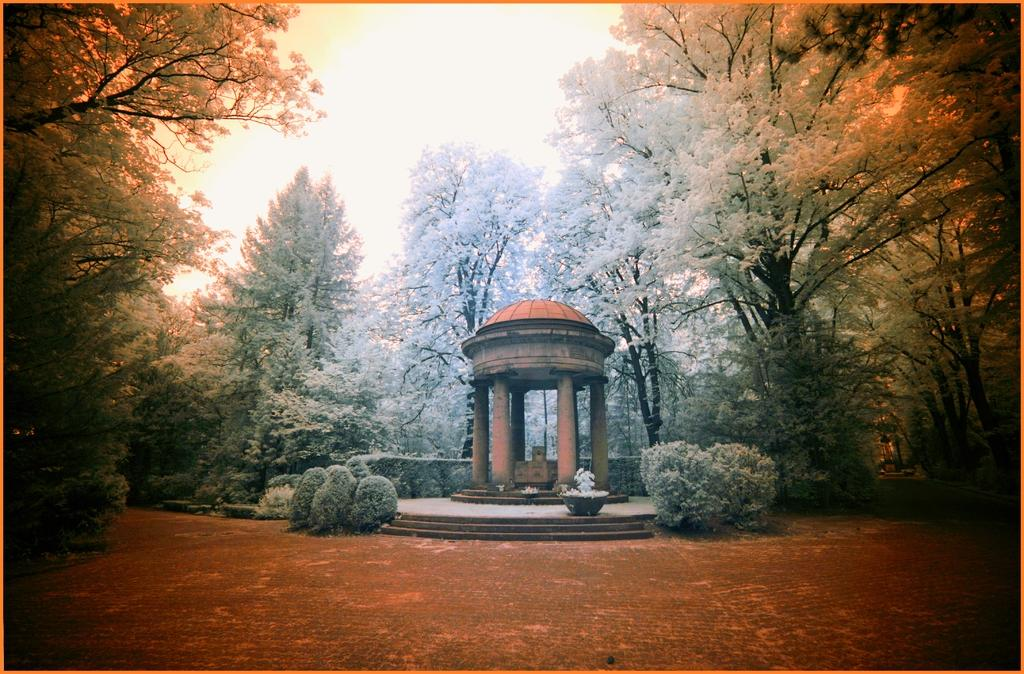What type of structure is on the ground in the image? There is a shed on the ground in the image. What type of plant can be seen inside the shed? There is a houseplant in the image. What other types of plants are visible in the image? There are plants and trees in the image. What else can be seen in the image besides plants and the shed? There are objects in the image. What is visible in the background of the image? The sky is visible in the background of the image. How does the shed help the plants learn to spy on the neighbors? The shed does not help the plants learn to spy on the neighbors; it is simply a structure on the ground. 